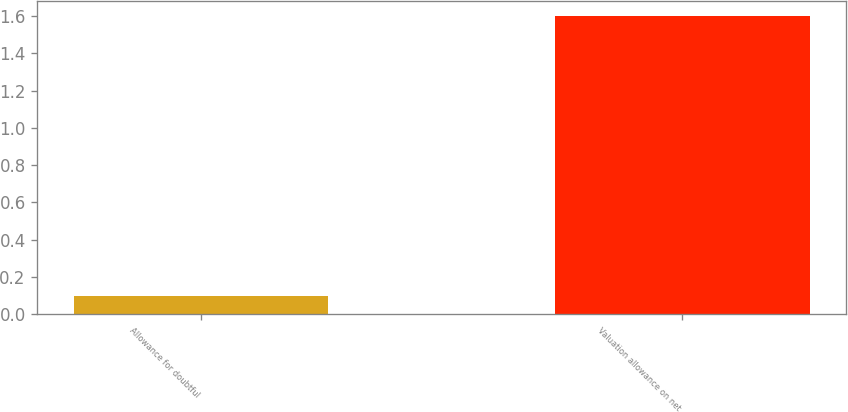Convert chart to OTSL. <chart><loc_0><loc_0><loc_500><loc_500><bar_chart><fcel>Allowance for doubtful<fcel>Valuation allowance on net<nl><fcel>0.1<fcel>1.6<nl></chart> 